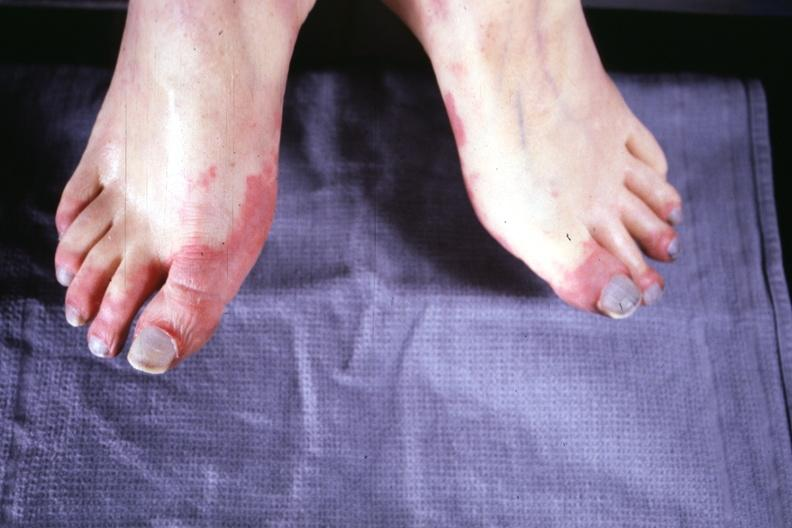re mitotic figures present?
Answer the question using a single word or phrase. No 